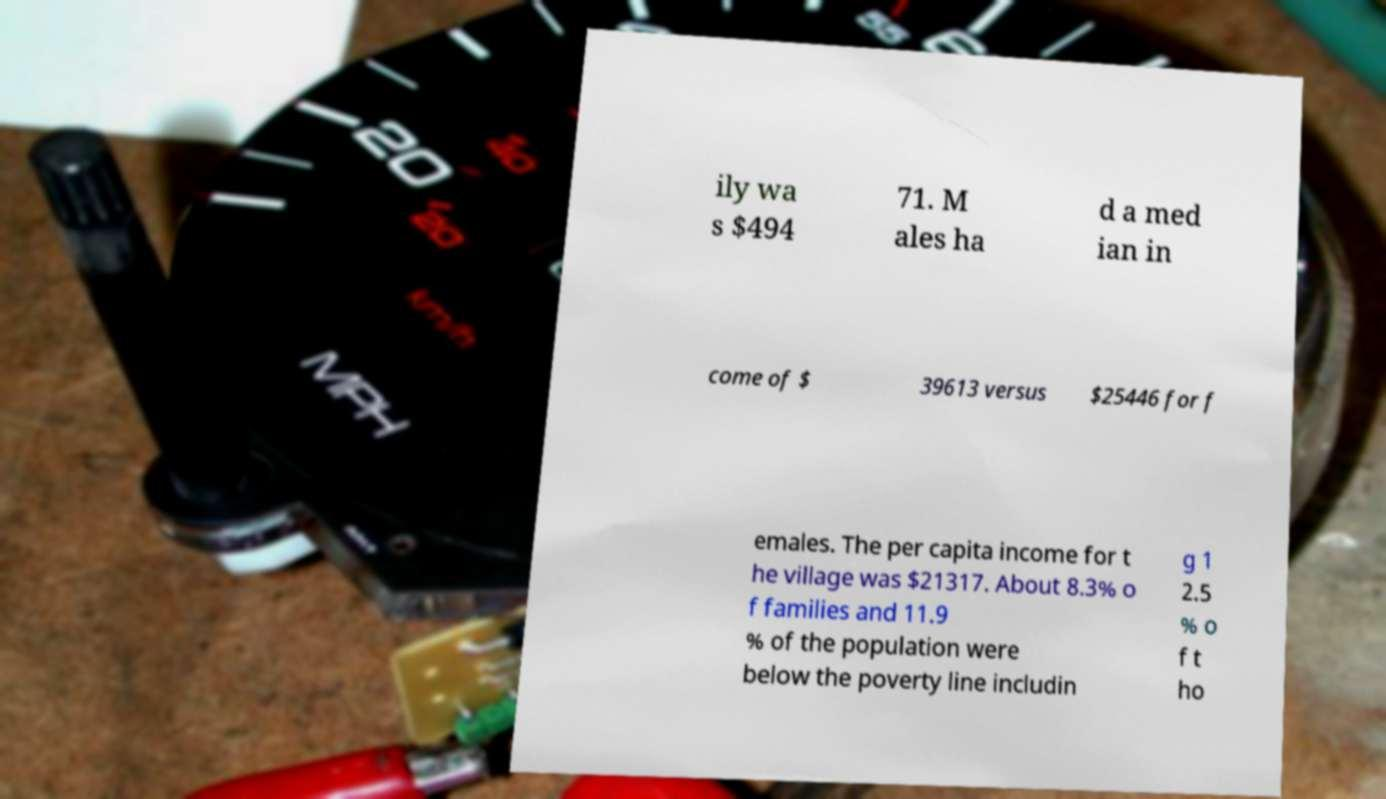Please identify and transcribe the text found in this image. ily wa s $494 71. M ales ha d a med ian in come of $ 39613 versus $25446 for f emales. The per capita income for t he village was $21317. About 8.3% o f families and 11.9 % of the population were below the poverty line includin g 1 2.5 % o f t ho 